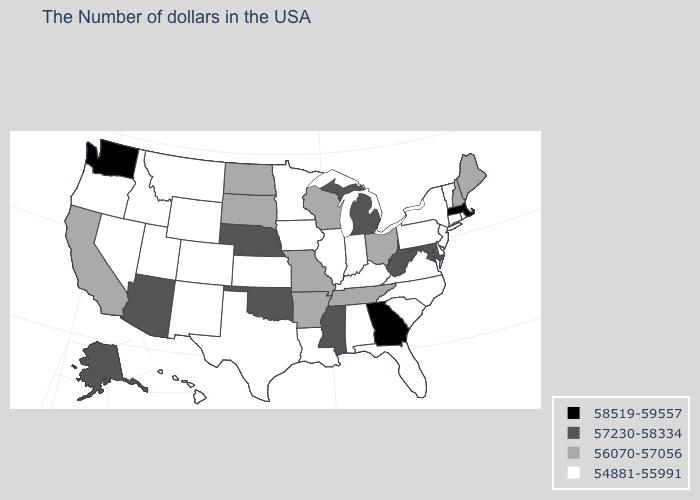What is the value of Massachusetts?
Give a very brief answer. 58519-59557. Name the states that have a value in the range 54881-55991?
Give a very brief answer. Rhode Island, Vermont, Connecticut, New York, New Jersey, Delaware, Pennsylvania, Virginia, North Carolina, South Carolina, Florida, Kentucky, Indiana, Alabama, Illinois, Louisiana, Minnesota, Iowa, Kansas, Texas, Wyoming, Colorado, New Mexico, Utah, Montana, Idaho, Nevada, Oregon, Hawaii. Among the states that border Utah , does New Mexico have the lowest value?
Answer briefly. Yes. Name the states that have a value in the range 57230-58334?
Short answer required. Maryland, West Virginia, Michigan, Mississippi, Nebraska, Oklahoma, Arizona, Alaska. Name the states that have a value in the range 57230-58334?
Give a very brief answer. Maryland, West Virginia, Michigan, Mississippi, Nebraska, Oklahoma, Arizona, Alaska. Name the states that have a value in the range 56070-57056?
Short answer required. Maine, New Hampshire, Ohio, Tennessee, Wisconsin, Missouri, Arkansas, South Dakota, North Dakota, California. Does the first symbol in the legend represent the smallest category?
Give a very brief answer. No. What is the value of California?
Concise answer only. 56070-57056. How many symbols are there in the legend?
Concise answer only. 4. What is the highest value in states that border Florida?
Keep it brief. 58519-59557. What is the highest value in states that border Colorado?
Write a very short answer. 57230-58334. Name the states that have a value in the range 56070-57056?
Write a very short answer. Maine, New Hampshire, Ohio, Tennessee, Wisconsin, Missouri, Arkansas, South Dakota, North Dakota, California. How many symbols are there in the legend?
Be succinct. 4. What is the value of North Carolina?
Short answer required. 54881-55991. What is the value of Maryland?
Short answer required. 57230-58334. 